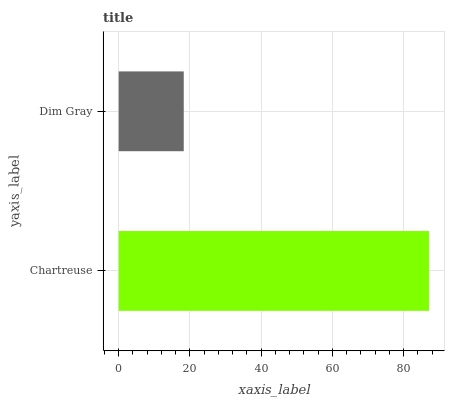Is Dim Gray the minimum?
Answer yes or no. Yes. Is Chartreuse the maximum?
Answer yes or no. Yes. Is Dim Gray the maximum?
Answer yes or no. No. Is Chartreuse greater than Dim Gray?
Answer yes or no. Yes. Is Dim Gray less than Chartreuse?
Answer yes or no. Yes. Is Dim Gray greater than Chartreuse?
Answer yes or no. No. Is Chartreuse less than Dim Gray?
Answer yes or no. No. Is Chartreuse the high median?
Answer yes or no. Yes. Is Dim Gray the low median?
Answer yes or no. Yes. Is Dim Gray the high median?
Answer yes or no. No. Is Chartreuse the low median?
Answer yes or no. No. 